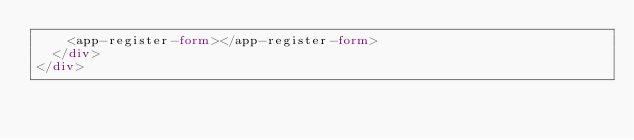<code> <loc_0><loc_0><loc_500><loc_500><_HTML_>    <app-register-form></app-register-form>
  </div>
</div></code> 